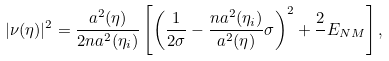<formula> <loc_0><loc_0><loc_500><loc_500>| { \nu } ( \eta ) | ^ { 2 } = \frac { a ^ { 2 } ( \eta ) } { 2 n a ^ { 2 } ( \eta _ { i } ) } \left [ \left ( \frac { 1 } { 2 \sigma } - \frac { n a ^ { 2 } ( \eta _ { i } ) } { a ^ { 2 } ( \eta ) } \sigma \right ) ^ { 2 } + \frac { 2 } { } E _ { N M } \right ] ,</formula> 